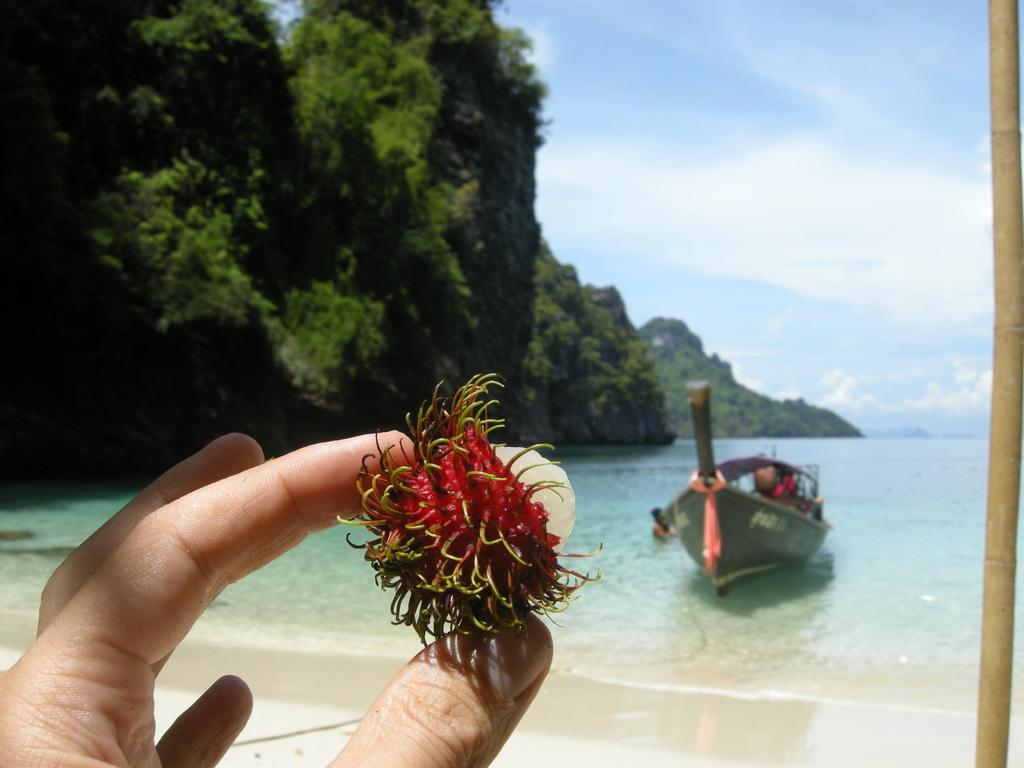What is the person in the image holding? The person is holding a fruit in the image. What can be seen in the background of the image? There is sand, a boat in the ocean, and mountains on the left side of the image. How is the sky depicted in the image? The sky is clear in the image. What type of business is being conducted in the image? There is no indication of any business being conducted in the image. 